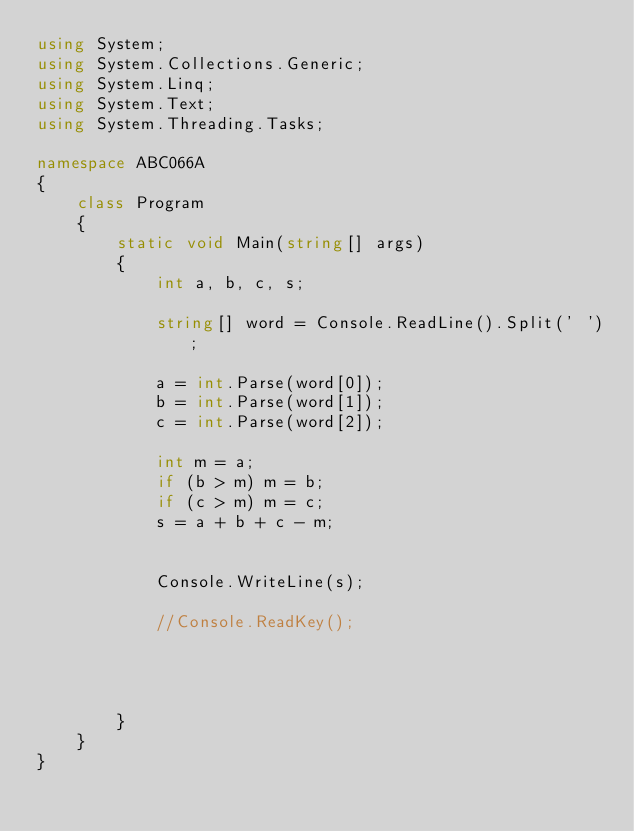Convert code to text. <code><loc_0><loc_0><loc_500><loc_500><_C#_>using System;
using System.Collections.Generic;
using System.Linq;
using System.Text;
using System.Threading.Tasks;

namespace ABC066A
{
    class Program
    {
        static void Main(string[] args)
        {
            int a, b, c, s;

            string[] word = Console.ReadLine().Split(' ');

            a = int.Parse(word[0]);
            b = int.Parse(word[1]);
            c = int.Parse(word[2]);

            int m = a;
            if (b > m) m = b;
            if (c > m) m = c;
            s = a + b + c - m;

  
            Console.WriteLine(s);

            //Console.ReadKey();
            
            

                
        }
    }
}
</code> 